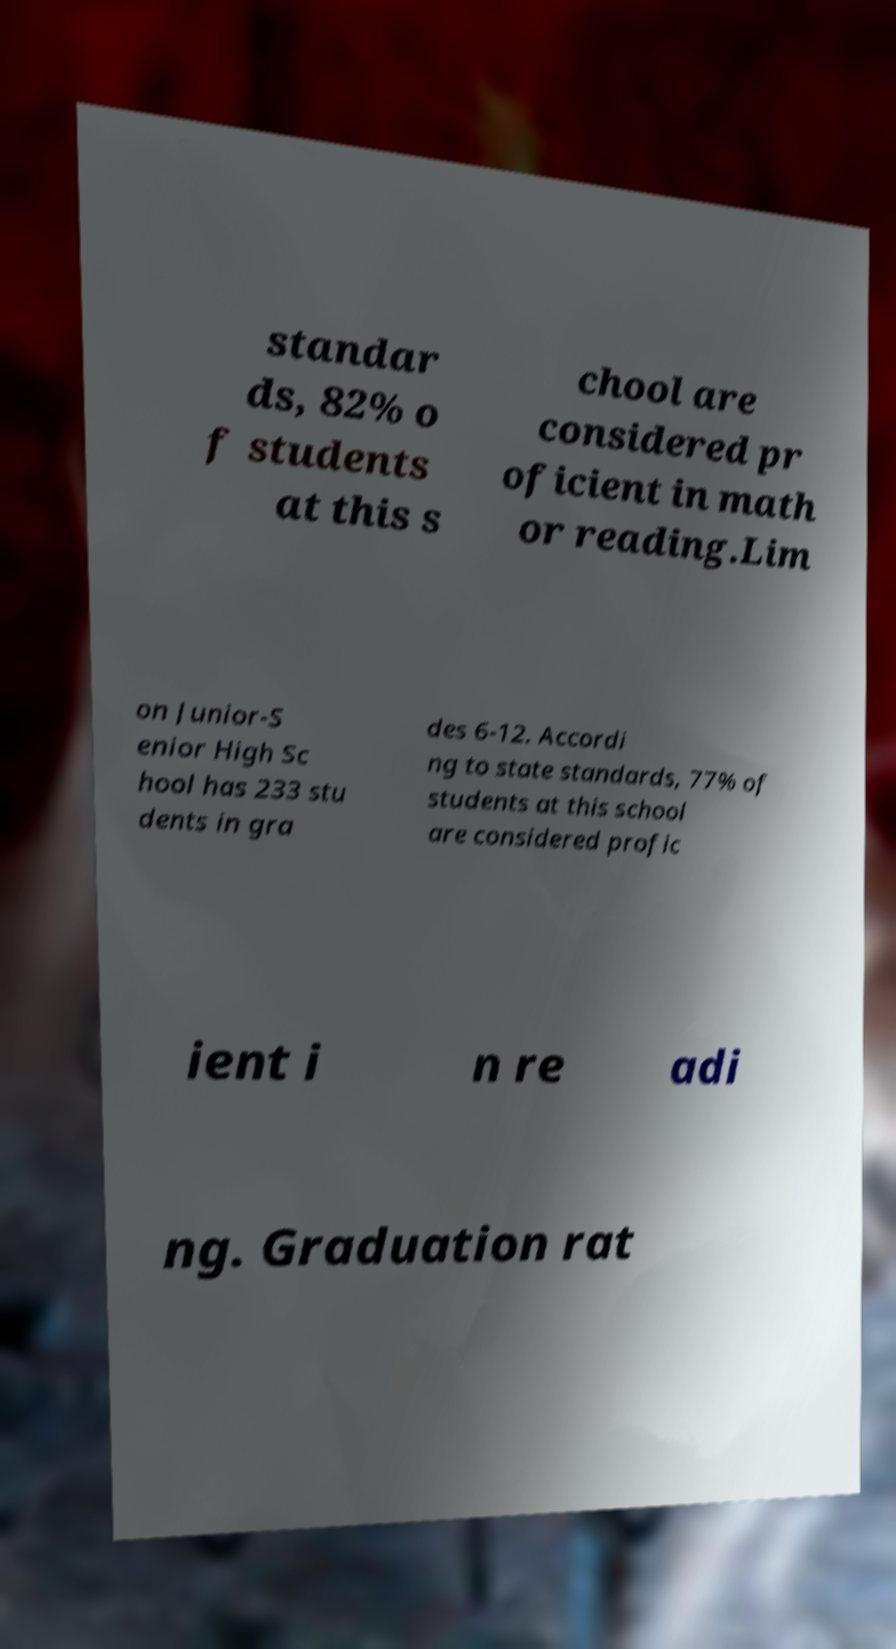Please identify and transcribe the text found in this image. standar ds, 82% o f students at this s chool are considered pr oficient in math or reading.Lim on Junior-S enior High Sc hool has 233 stu dents in gra des 6-12. Accordi ng to state standards, 77% of students at this school are considered profic ient i n re adi ng. Graduation rat 